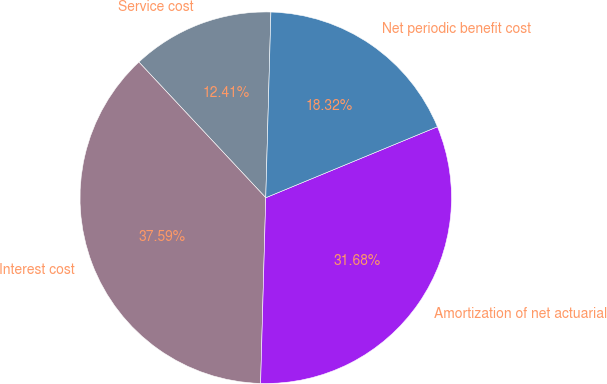Convert chart to OTSL. <chart><loc_0><loc_0><loc_500><loc_500><pie_chart><fcel>Service cost<fcel>Interest cost<fcel>Amortization of net actuarial<fcel>Net periodic benefit cost<nl><fcel>12.41%<fcel>37.59%<fcel>31.68%<fcel>18.32%<nl></chart> 